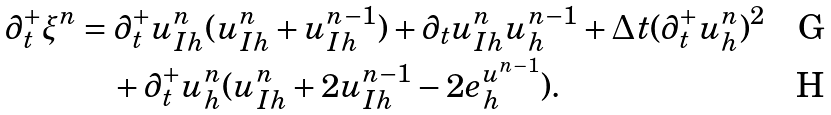Convert formula to latex. <formula><loc_0><loc_0><loc_500><loc_500>\partial _ { t } ^ { + } \xi ^ { n } & = \partial _ { t } ^ { + } u _ { I h } ^ { n } ( u _ { I h } ^ { n } + u _ { I h } ^ { n - 1 } ) + \partial _ { t } u _ { I h } ^ { n } u _ { h } ^ { n - 1 } + \Delta t ( \partial _ { t } ^ { + } u _ { h } ^ { n } ) ^ { 2 } \\ & \quad + \partial _ { t } ^ { + } u _ { h } ^ { n } ( u _ { I h } ^ { n } + 2 u _ { I h } ^ { n - 1 } - 2 e _ { h } ^ { u ^ { n - 1 } } ) .</formula> 